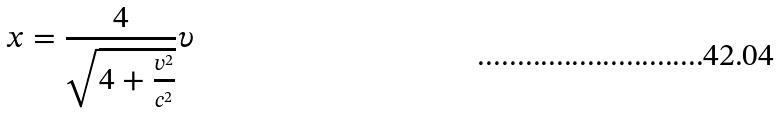Convert formula to latex. <formula><loc_0><loc_0><loc_500><loc_500>x = \frac { 4 } { \sqrt { 4 + \frac { v ^ { 2 } } { c ^ { 2 } } } } \upsilon</formula> 